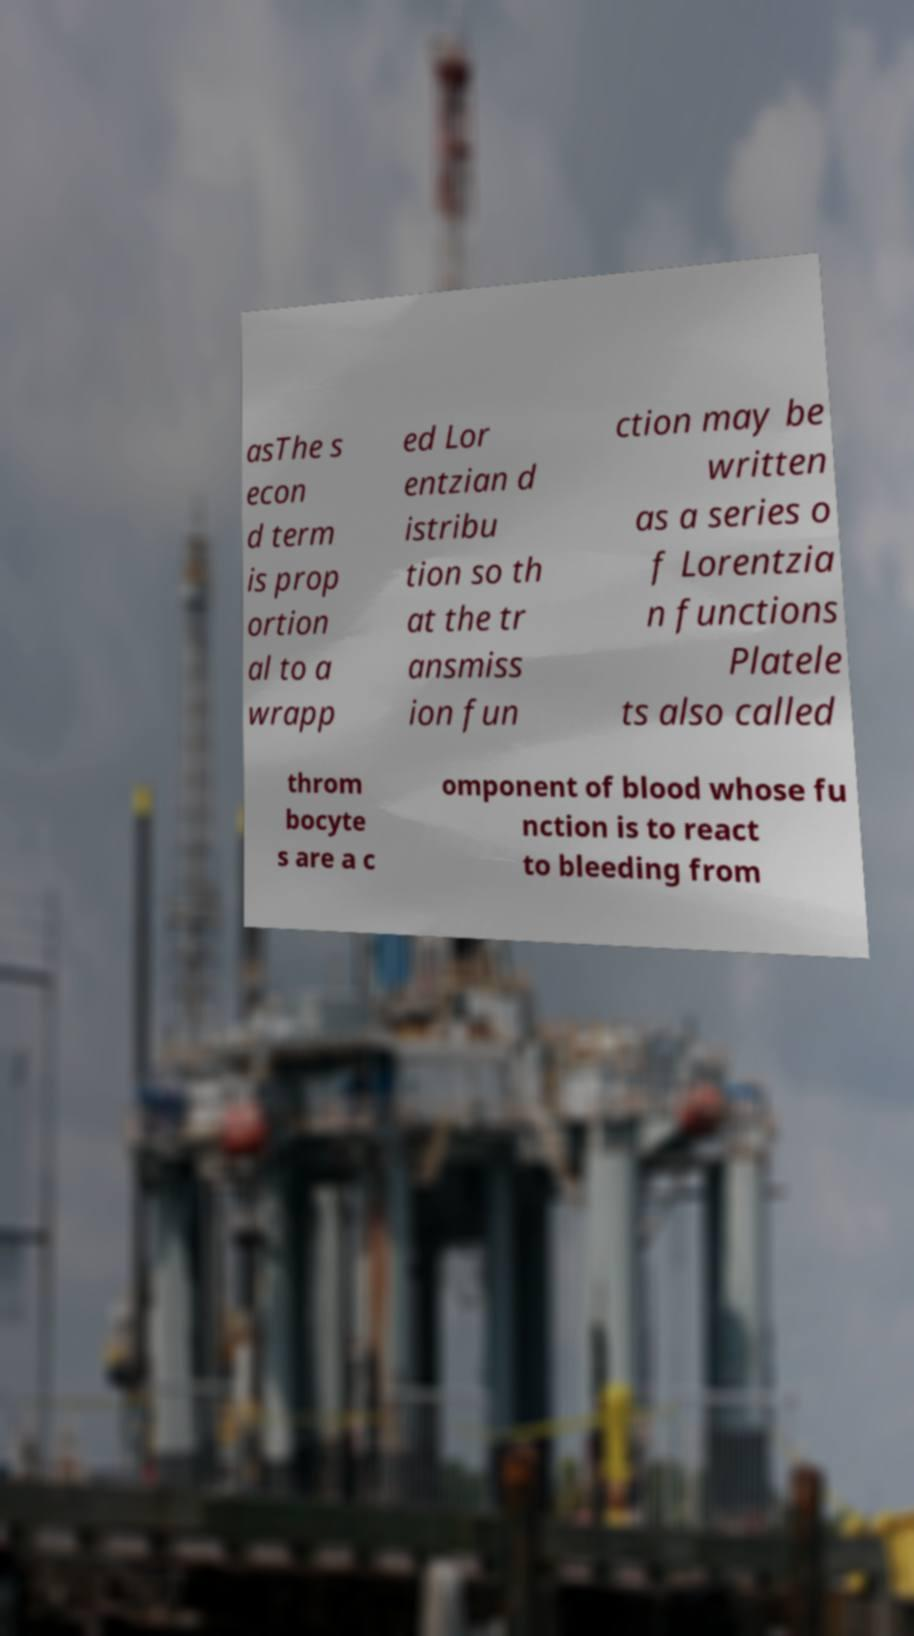Can you accurately transcribe the text from the provided image for me? asThe s econ d term is prop ortion al to a wrapp ed Lor entzian d istribu tion so th at the tr ansmiss ion fun ction may be written as a series o f Lorentzia n functions Platele ts also called throm bocyte s are a c omponent of blood whose fu nction is to react to bleeding from 